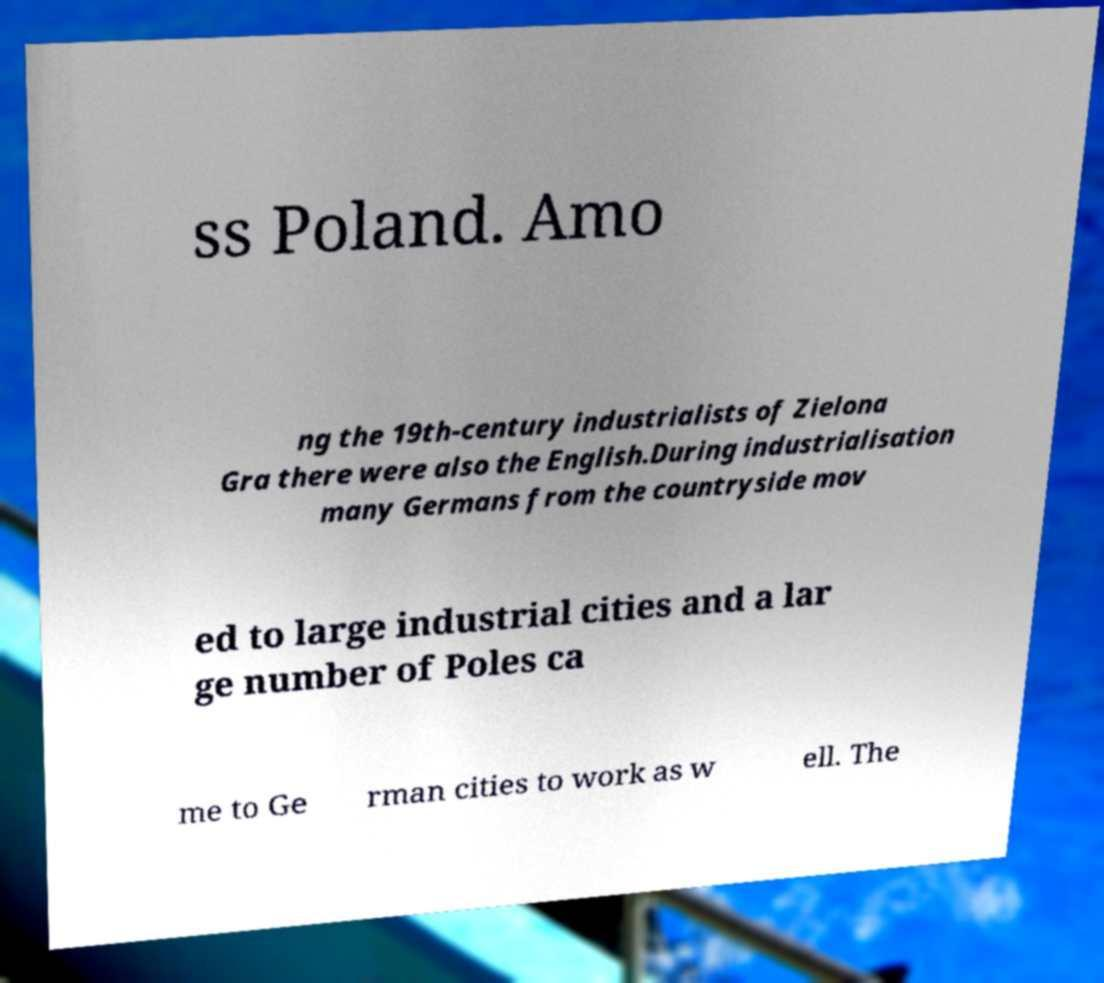Can you accurately transcribe the text from the provided image for me? ss Poland. Amo ng the 19th-century industrialists of Zielona Gra there were also the English.During industrialisation many Germans from the countryside mov ed to large industrial cities and a lar ge number of Poles ca me to Ge rman cities to work as w ell. The 